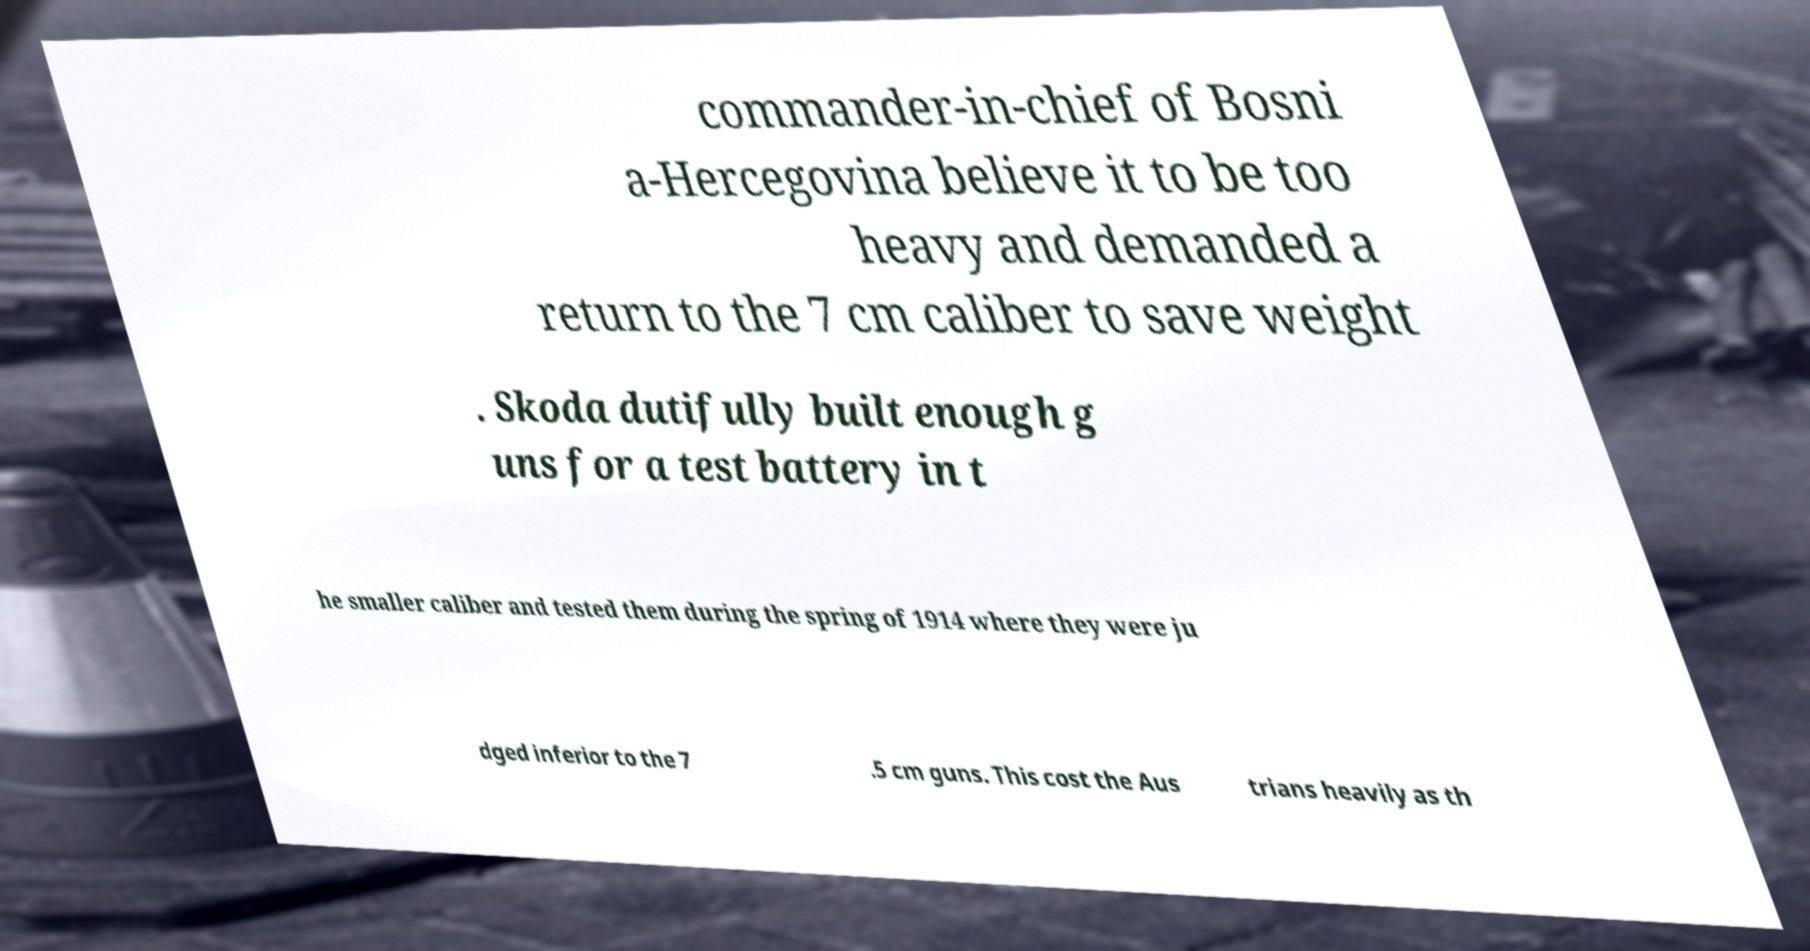For documentation purposes, I need the text within this image transcribed. Could you provide that? commander-in-chief of Bosni a-Hercegovina believe it to be too heavy and demanded a return to the 7 cm caliber to save weight . Skoda dutifully built enough g uns for a test battery in t he smaller caliber and tested them during the spring of 1914 where they were ju dged inferior to the 7 .5 cm guns. This cost the Aus trians heavily as th 